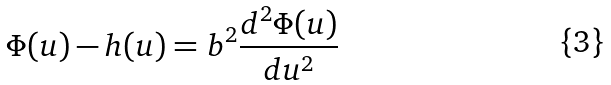Convert formula to latex. <formula><loc_0><loc_0><loc_500><loc_500>\Phi ( u ) - h ( u ) = b ^ { 2 } \frac { d ^ { 2 } \Phi ( u ) } { d u ^ { 2 } }</formula> 